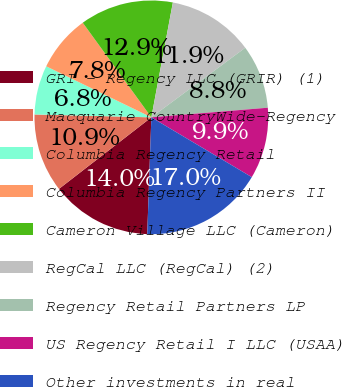Convert chart. <chart><loc_0><loc_0><loc_500><loc_500><pie_chart><fcel>GRI - Regency LLC (GRIR) (1)<fcel>Macquarie CountryWide-Regency<fcel>Columbia Regency Retail<fcel>Columbia Regency Partners II<fcel>Cameron Village LLC (Cameron)<fcel>RegCal LLC (RegCal) (2)<fcel>Regency Retail Partners LP<fcel>US Regency Retail I LLC (USAA)<fcel>Other investments in real<nl><fcel>13.95%<fcel>10.88%<fcel>6.8%<fcel>7.82%<fcel>12.93%<fcel>11.9%<fcel>8.84%<fcel>9.86%<fcel>17.01%<nl></chart> 